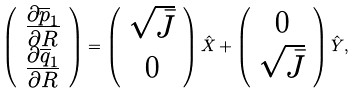<formula> <loc_0><loc_0><loc_500><loc_500>\left ( \begin{array} { c } \frac { \partial \overline { p } _ { 1 } } { \partial R } \\ \frac { \partial \overline { q } _ { 1 } } { \partial R } \end{array} \right ) = \left ( \begin{array} { c } \sqrt { \bar { J } } \\ 0 \end{array} \right ) \hat { X } + \left ( \begin{array} { c } 0 \\ \sqrt { \bar { J } } \end{array} \right ) \hat { Y } ,</formula> 